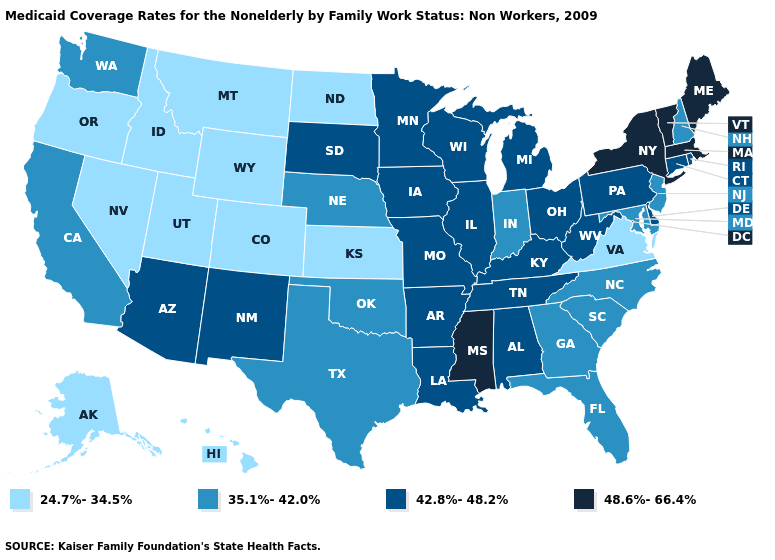Which states have the lowest value in the USA?
Be succinct. Alaska, Colorado, Hawaii, Idaho, Kansas, Montana, Nevada, North Dakota, Oregon, Utah, Virginia, Wyoming. Among the states that border Arizona , which have the highest value?
Short answer required. New Mexico. Which states have the lowest value in the USA?
Write a very short answer. Alaska, Colorado, Hawaii, Idaho, Kansas, Montana, Nevada, North Dakota, Oregon, Utah, Virginia, Wyoming. Name the states that have a value in the range 24.7%-34.5%?
Short answer required. Alaska, Colorado, Hawaii, Idaho, Kansas, Montana, Nevada, North Dakota, Oregon, Utah, Virginia, Wyoming. What is the value of Arkansas?
Quick response, please. 42.8%-48.2%. What is the value of New Hampshire?
Keep it brief. 35.1%-42.0%. What is the value of Arkansas?
Quick response, please. 42.8%-48.2%. Does Arizona have a lower value than Massachusetts?
Keep it brief. Yes. Among the states that border Washington , which have the highest value?
Quick response, please. Idaho, Oregon. What is the highest value in the Northeast ?
Keep it brief. 48.6%-66.4%. Which states have the highest value in the USA?
Answer briefly. Maine, Massachusetts, Mississippi, New York, Vermont. What is the value of Maine?
Be succinct. 48.6%-66.4%. Which states have the highest value in the USA?
Quick response, please. Maine, Massachusetts, Mississippi, New York, Vermont. Does Alabama have the lowest value in the South?
Short answer required. No. Name the states that have a value in the range 24.7%-34.5%?
Short answer required. Alaska, Colorado, Hawaii, Idaho, Kansas, Montana, Nevada, North Dakota, Oregon, Utah, Virginia, Wyoming. 